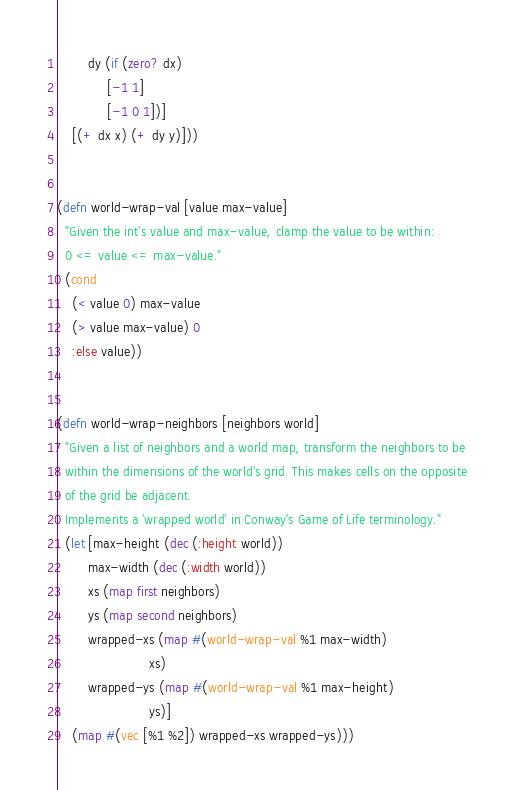<code> <loc_0><loc_0><loc_500><loc_500><_Clojure_>        dy (if (zero? dx)
             [-1 1]
             [-1 0 1])]
    [(+ dx x) (+ dy y)]))


(defn world-wrap-val [value max-value]
  "Given the int's value and max-value, clamp the value to be within:
  0 <= value <= max-value."
  (cond
    (< value 0) max-value
    (> value max-value) 0
    :else value))


(defn world-wrap-neighbors [neighbors world]
  "Given a list of neighbors and a world map, transform the neighbors to be
  within the dimensions of the world's grid. This makes cells on the opposite
  of the grid be adjacent.
  Implements a 'wrapped world' in Conway's Game of Life terminology."
  (let [max-height (dec (:height world))
        max-width (dec (:width world))
        xs (map first neighbors)
        ys (map second neighbors)
        wrapped-xs (map #(world-wrap-val %1 max-width)
                        xs)
        wrapped-ys (map #(world-wrap-val %1 max-height)
                        ys)]
    (map #(vec [%1 %2]) wrapped-xs wrapped-ys)))
</code> 